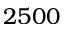<formula> <loc_0><loc_0><loc_500><loc_500>2 5 0 0</formula> 